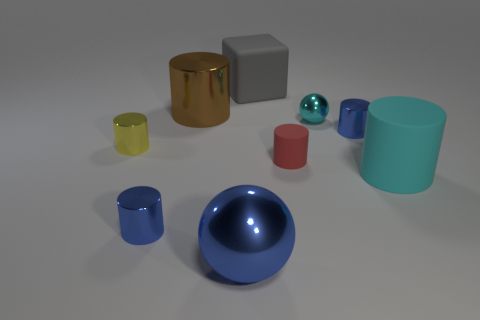How does lighting affect the appearance of the objects? The lighting in the image creates soft shadows and enhances the three-dimensionality of the objects. It also brings out the glossiness of the reflective objects and emphasizes the textures of the matte ones, contributing to the overall depth and realism of the scene. Is there any indication of the light source's direction in this image? The direction of the light source can be inferred from the shadows cast by the objects. They appear to fall slightly to the left and towards the front of the image, which suggests that the light source is positioned to the right and towards the back of the scene. 